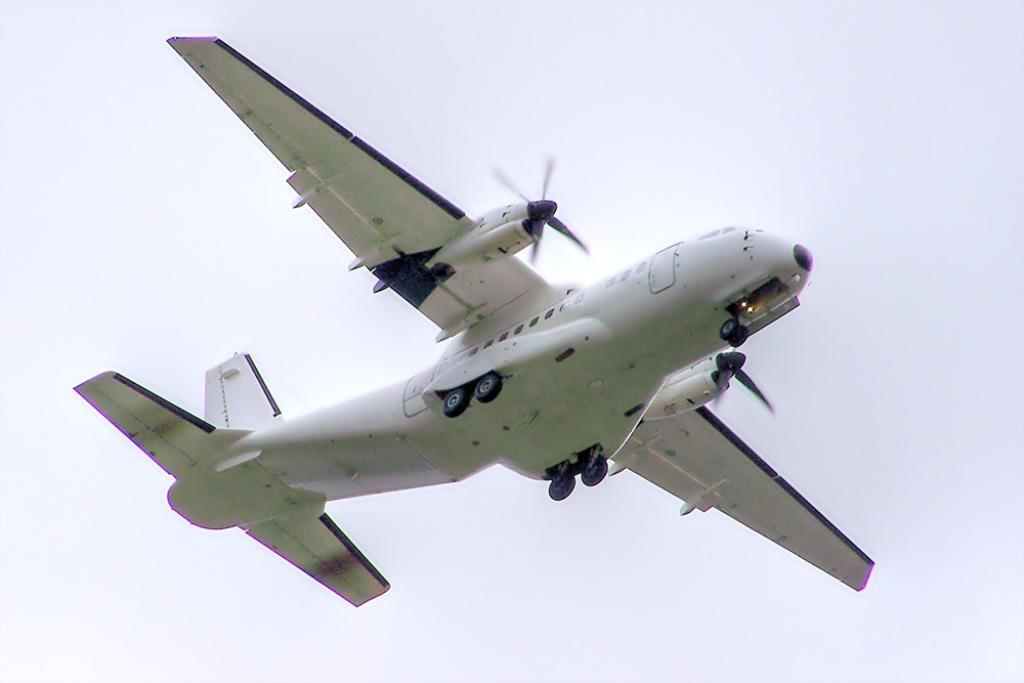What is the main subject of the image? The main subject of the image is a plane. Can you describe the plane's position in the image? The plane is in the air in the image. What color is the background of the image? The background of the image is white. How many sheep can be seen grazing in the image? There are no sheep present in the image. What type of dress is the plane wearing in the image? Planes do not wear dresses, as they are inanimate objects. 